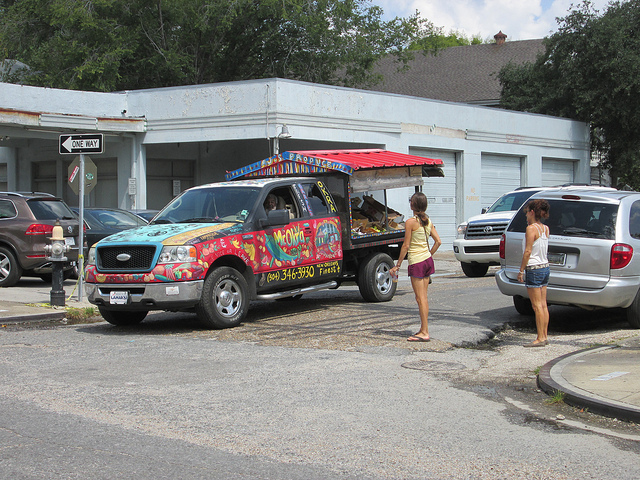Please extract the text content from this image. 346 3930 